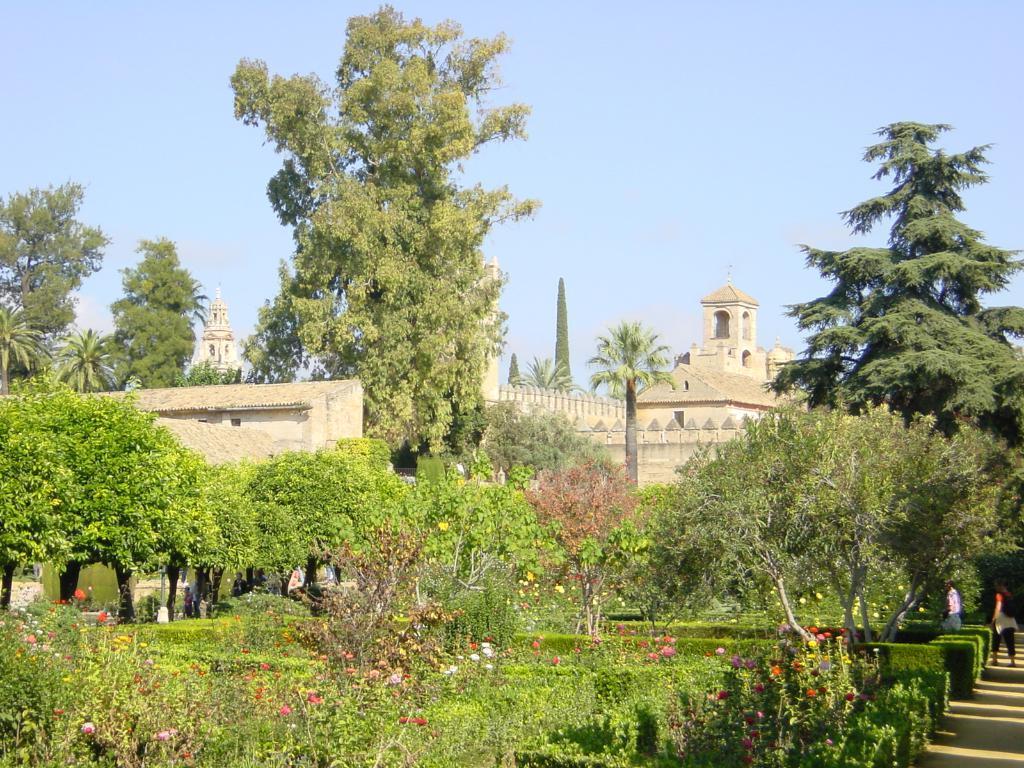Can you describe this image briefly? We can see plants, flowers, trees and buildings. There are people. In the background we can see sky. 